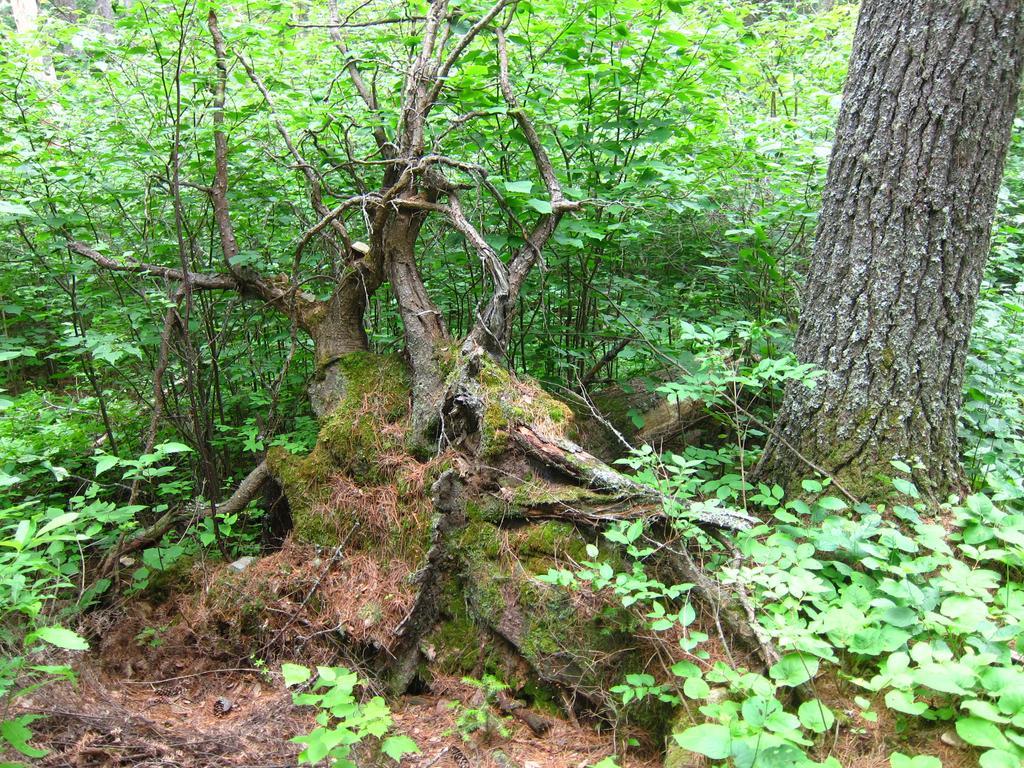Can you describe this image briefly? In this image we can see a group of plants and the bark of a tree. 